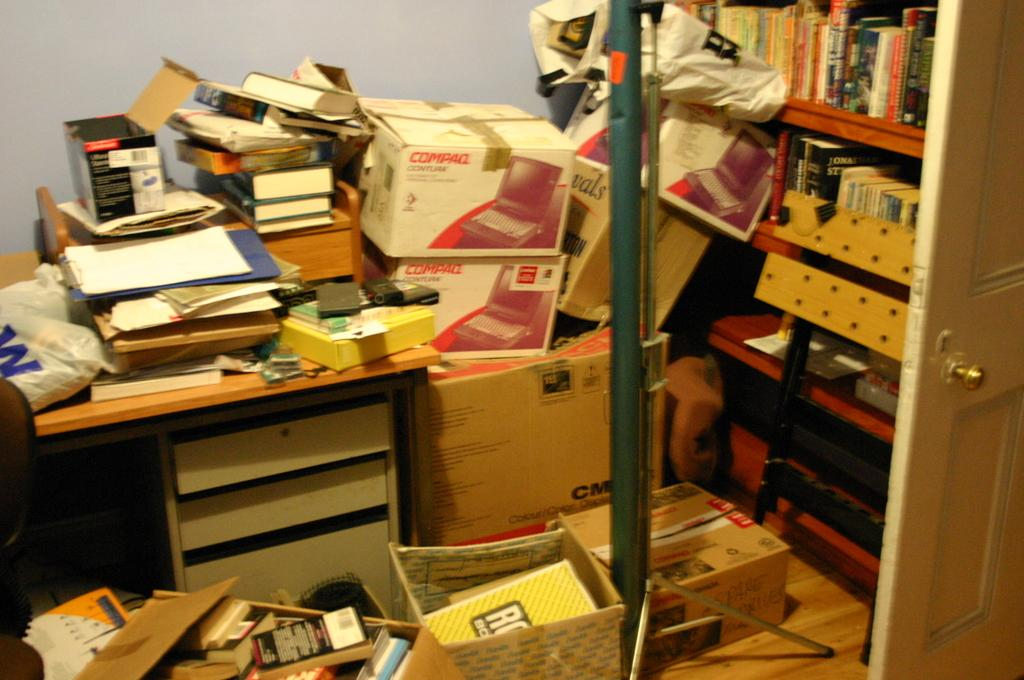<image>
Relay a brief, clear account of the picture shown. A messy room has two boxes that say Compaq. 